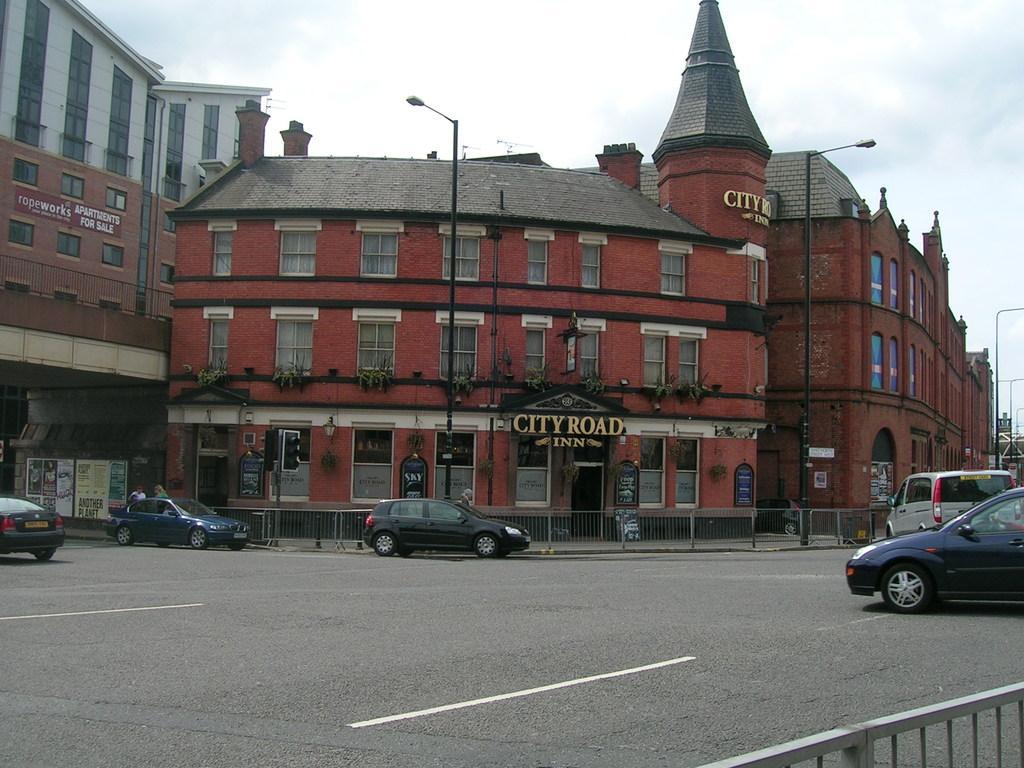In one or two sentences, can you explain what this image depicts? As we can see in the image there are buildings, street lamps, fence, banner and cars. On the top there is sky. 